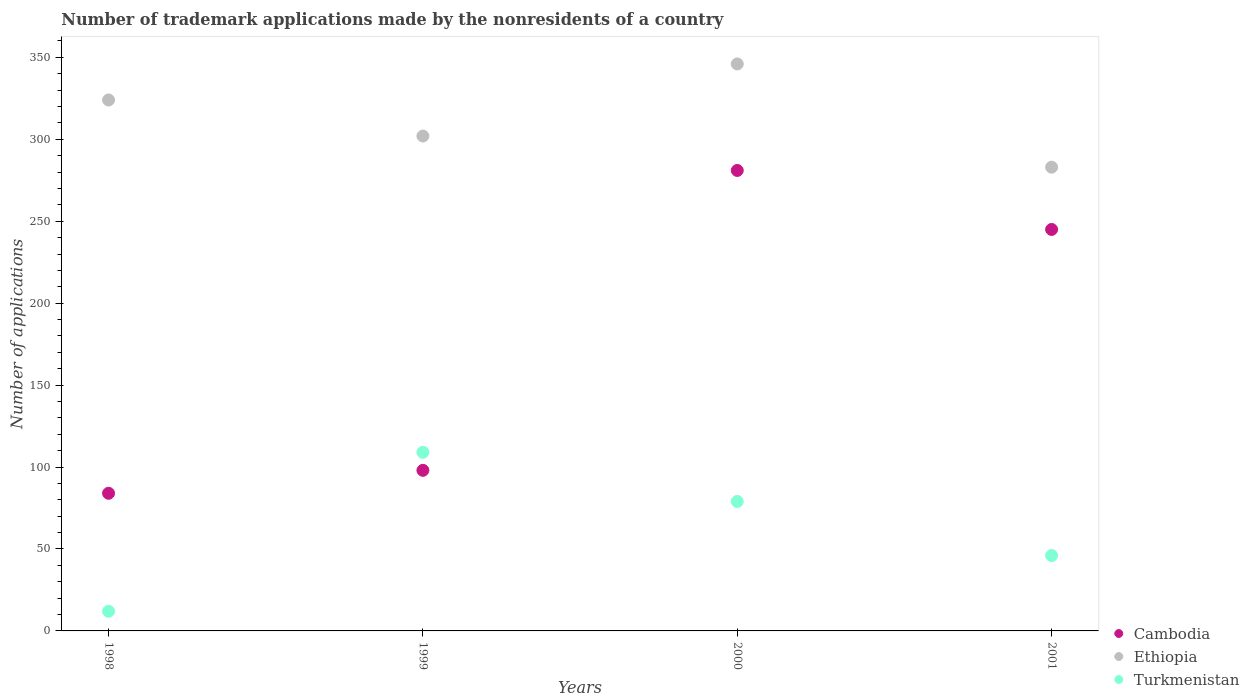How many different coloured dotlines are there?
Your answer should be compact. 3. What is the number of trademark applications made by the nonresidents in Ethiopia in 1999?
Your answer should be very brief. 302. Across all years, what is the maximum number of trademark applications made by the nonresidents in Cambodia?
Ensure brevity in your answer.  281. In which year was the number of trademark applications made by the nonresidents in Ethiopia maximum?
Give a very brief answer. 2000. What is the total number of trademark applications made by the nonresidents in Turkmenistan in the graph?
Keep it short and to the point. 246. What is the difference between the number of trademark applications made by the nonresidents in Cambodia in 1998 and that in 2000?
Your response must be concise. -197. What is the average number of trademark applications made by the nonresidents in Ethiopia per year?
Provide a short and direct response. 313.75. In the year 2000, what is the difference between the number of trademark applications made by the nonresidents in Cambodia and number of trademark applications made by the nonresidents in Ethiopia?
Give a very brief answer. -65. What is the ratio of the number of trademark applications made by the nonresidents in Cambodia in 1998 to that in 2001?
Offer a very short reply. 0.34. What is the difference between the highest and the second highest number of trademark applications made by the nonresidents in Cambodia?
Your answer should be compact. 36. What is the difference between the highest and the lowest number of trademark applications made by the nonresidents in Turkmenistan?
Provide a short and direct response. 97. Does the number of trademark applications made by the nonresidents in Cambodia monotonically increase over the years?
Give a very brief answer. No. Are the values on the major ticks of Y-axis written in scientific E-notation?
Ensure brevity in your answer.  No. Where does the legend appear in the graph?
Your answer should be compact. Bottom right. How many legend labels are there?
Provide a short and direct response. 3. What is the title of the graph?
Give a very brief answer. Number of trademark applications made by the nonresidents of a country. What is the label or title of the Y-axis?
Your answer should be very brief. Number of applications. What is the Number of applications of Cambodia in 1998?
Offer a terse response. 84. What is the Number of applications of Ethiopia in 1998?
Your response must be concise. 324. What is the Number of applications in Cambodia in 1999?
Make the answer very short. 98. What is the Number of applications of Ethiopia in 1999?
Give a very brief answer. 302. What is the Number of applications of Turkmenistan in 1999?
Keep it short and to the point. 109. What is the Number of applications in Cambodia in 2000?
Provide a succinct answer. 281. What is the Number of applications of Ethiopia in 2000?
Provide a succinct answer. 346. What is the Number of applications of Turkmenistan in 2000?
Make the answer very short. 79. What is the Number of applications in Cambodia in 2001?
Offer a very short reply. 245. What is the Number of applications of Ethiopia in 2001?
Your response must be concise. 283. Across all years, what is the maximum Number of applications in Cambodia?
Offer a very short reply. 281. Across all years, what is the maximum Number of applications in Ethiopia?
Offer a very short reply. 346. Across all years, what is the maximum Number of applications in Turkmenistan?
Your answer should be compact. 109. Across all years, what is the minimum Number of applications in Cambodia?
Your answer should be compact. 84. Across all years, what is the minimum Number of applications in Ethiopia?
Provide a succinct answer. 283. What is the total Number of applications of Cambodia in the graph?
Provide a short and direct response. 708. What is the total Number of applications in Ethiopia in the graph?
Offer a very short reply. 1255. What is the total Number of applications of Turkmenistan in the graph?
Make the answer very short. 246. What is the difference between the Number of applications of Cambodia in 1998 and that in 1999?
Your answer should be compact. -14. What is the difference between the Number of applications of Ethiopia in 1998 and that in 1999?
Give a very brief answer. 22. What is the difference between the Number of applications of Turkmenistan in 1998 and that in 1999?
Provide a succinct answer. -97. What is the difference between the Number of applications in Cambodia in 1998 and that in 2000?
Give a very brief answer. -197. What is the difference between the Number of applications of Ethiopia in 1998 and that in 2000?
Your answer should be very brief. -22. What is the difference between the Number of applications of Turkmenistan in 1998 and that in 2000?
Your answer should be compact. -67. What is the difference between the Number of applications in Cambodia in 1998 and that in 2001?
Make the answer very short. -161. What is the difference between the Number of applications in Turkmenistan in 1998 and that in 2001?
Keep it short and to the point. -34. What is the difference between the Number of applications of Cambodia in 1999 and that in 2000?
Provide a succinct answer. -183. What is the difference between the Number of applications in Ethiopia in 1999 and that in 2000?
Provide a succinct answer. -44. What is the difference between the Number of applications in Cambodia in 1999 and that in 2001?
Your answer should be very brief. -147. What is the difference between the Number of applications of Ethiopia in 1999 and that in 2001?
Ensure brevity in your answer.  19. What is the difference between the Number of applications of Cambodia in 2000 and that in 2001?
Offer a terse response. 36. What is the difference between the Number of applications of Ethiopia in 2000 and that in 2001?
Keep it short and to the point. 63. What is the difference between the Number of applications in Turkmenistan in 2000 and that in 2001?
Your response must be concise. 33. What is the difference between the Number of applications in Cambodia in 1998 and the Number of applications in Ethiopia in 1999?
Ensure brevity in your answer.  -218. What is the difference between the Number of applications in Ethiopia in 1998 and the Number of applications in Turkmenistan in 1999?
Provide a succinct answer. 215. What is the difference between the Number of applications in Cambodia in 1998 and the Number of applications in Ethiopia in 2000?
Offer a terse response. -262. What is the difference between the Number of applications in Ethiopia in 1998 and the Number of applications in Turkmenistan in 2000?
Offer a terse response. 245. What is the difference between the Number of applications in Cambodia in 1998 and the Number of applications in Ethiopia in 2001?
Offer a terse response. -199. What is the difference between the Number of applications of Cambodia in 1998 and the Number of applications of Turkmenistan in 2001?
Ensure brevity in your answer.  38. What is the difference between the Number of applications in Ethiopia in 1998 and the Number of applications in Turkmenistan in 2001?
Offer a very short reply. 278. What is the difference between the Number of applications in Cambodia in 1999 and the Number of applications in Ethiopia in 2000?
Your response must be concise. -248. What is the difference between the Number of applications in Cambodia in 1999 and the Number of applications in Turkmenistan in 2000?
Provide a succinct answer. 19. What is the difference between the Number of applications in Ethiopia in 1999 and the Number of applications in Turkmenistan in 2000?
Your answer should be compact. 223. What is the difference between the Number of applications in Cambodia in 1999 and the Number of applications in Ethiopia in 2001?
Provide a succinct answer. -185. What is the difference between the Number of applications of Cambodia in 1999 and the Number of applications of Turkmenistan in 2001?
Make the answer very short. 52. What is the difference between the Number of applications of Ethiopia in 1999 and the Number of applications of Turkmenistan in 2001?
Offer a terse response. 256. What is the difference between the Number of applications in Cambodia in 2000 and the Number of applications in Turkmenistan in 2001?
Give a very brief answer. 235. What is the difference between the Number of applications in Ethiopia in 2000 and the Number of applications in Turkmenistan in 2001?
Keep it short and to the point. 300. What is the average Number of applications in Cambodia per year?
Ensure brevity in your answer.  177. What is the average Number of applications in Ethiopia per year?
Give a very brief answer. 313.75. What is the average Number of applications in Turkmenistan per year?
Keep it short and to the point. 61.5. In the year 1998, what is the difference between the Number of applications of Cambodia and Number of applications of Ethiopia?
Offer a terse response. -240. In the year 1998, what is the difference between the Number of applications in Ethiopia and Number of applications in Turkmenistan?
Your response must be concise. 312. In the year 1999, what is the difference between the Number of applications of Cambodia and Number of applications of Ethiopia?
Provide a succinct answer. -204. In the year 1999, what is the difference between the Number of applications in Cambodia and Number of applications in Turkmenistan?
Offer a terse response. -11. In the year 1999, what is the difference between the Number of applications in Ethiopia and Number of applications in Turkmenistan?
Offer a terse response. 193. In the year 2000, what is the difference between the Number of applications of Cambodia and Number of applications of Ethiopia?
Offer a very short reply. -65. In the year 2000, what is the difference between the Number of applications in Cambodia and Number of applications in Turkmenistan?
Offer a terse response. 202. In the year 2000, what is the difference between the Number of applications of Ethiopia and Number of applications of Turkmenistan?
Offer a terse response. 267. In the year 2001, what is the difference between the Number of applications in Cambodia and Number of applications in Ethiopia?
Keep it short and to the point. -38. In the year 2001, what is the difference between the Number of applications of Cambodia and Number of applications of Turkmenistan?
Your answer should be compact. 199. In the year 2001, what is the difference between the Number of applications of Ethiopia and Number of applications of Turkmenistan?
Your response must be concise. 237. What is the ratio of the Number of applications of Cambodia in 1998 to that in 1999?
Your answer should be very brief. 0.86. What is the ratio of the Number of applications of Ethiopia in 1998 to that in 1999?
Your response must be concise. 1.07. What is the ratio of the Number of applications in Turkmenistan in 1998 to that in 1999?
Offer a terse response. 0.11. What is the ratio of the Number of applications in Cambodia in 1998 to that in 2000?
Your response must be concise. 0.3. What is the ratio of the Number of applications in Ethiopia in 1998 to that in 2000?
Your answer should be very brief. 0.94. What is the ratio of the Number of applications in Turkmenistan in 1998 to that in 2000?
Offer a very short reply. 0.15. What is the ratio of the Number of applications in Cambodia in 1998 to that in 2001?
Your answer should be very brief. 0.34. What is the ratio of the Number of applications in Ethiopia in 1998 to that in 2001?
Your response must be concise. 1.14. What is the ratio of the Number of applications in Turkmenistan in 1998 to that in 2001?
Your response must be concise. 0.26. What is the ratio of the Number of applications of Cambodia in 1999 to that in 2000?
Your response must be concise. 0.35. What is the ratio of the Number of applications of Ethiopia in 1999 to that in 2000?
Give a very brief answer. 0.87. What is the ratio of the Number of applications of Turkmenistan in 1999 to that in 2000?
Provide a short and direct response. 1.38. What is the ratio of the Number of applications of Ethiopia in 1999 to that in 2001?
Your response must be concise. 1.07. What is the ratio of the Number of applications of Turkmenistan in 1999 to that in 2001?
Ensure brevity in your answer.  2.37. What is the ratio of the Number of applications in Cambodia in 2000 to that in 2001?
Make the answer very short. 1.15. What is the ratio of the Number of applications of Ethiopia in 2000 to that in 2001?
Your answer should be very brief. 1.22. What is the ratio of the Number of applications in Turkmenistan in 2000 to that in 2001?
Offer a terse response. 1.72. What is the difference between the highest and the second highest Number of applications in Turkmenistan?
Your answer should be very brief. 30. What is the difference between the highest and the lowest Number of applications in Cambodia?
Provide a succinct answer. 197. What is the difference between the highest and the lowest Number of applications of Turkmenistan?
Your answer should be very brief. 97. 